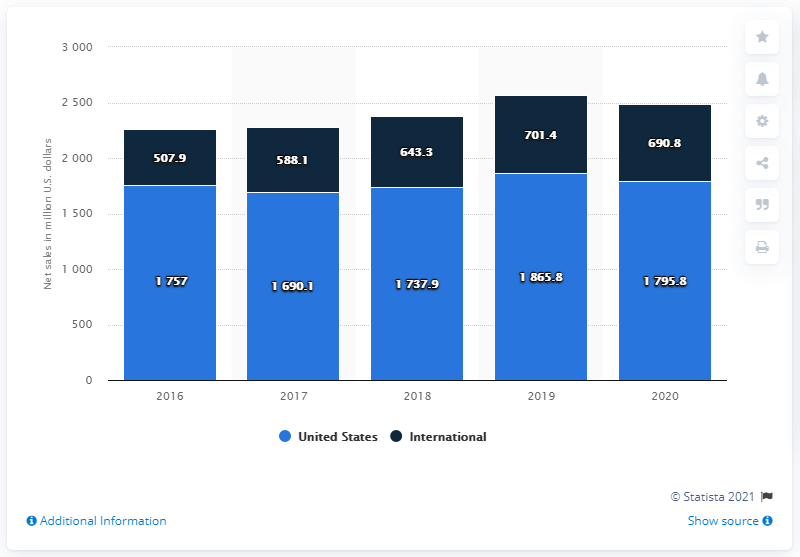Mention a couple of crucial points in this snapshot. In 2020, Herman Miller's net sales in the United States were $179.58 million. 